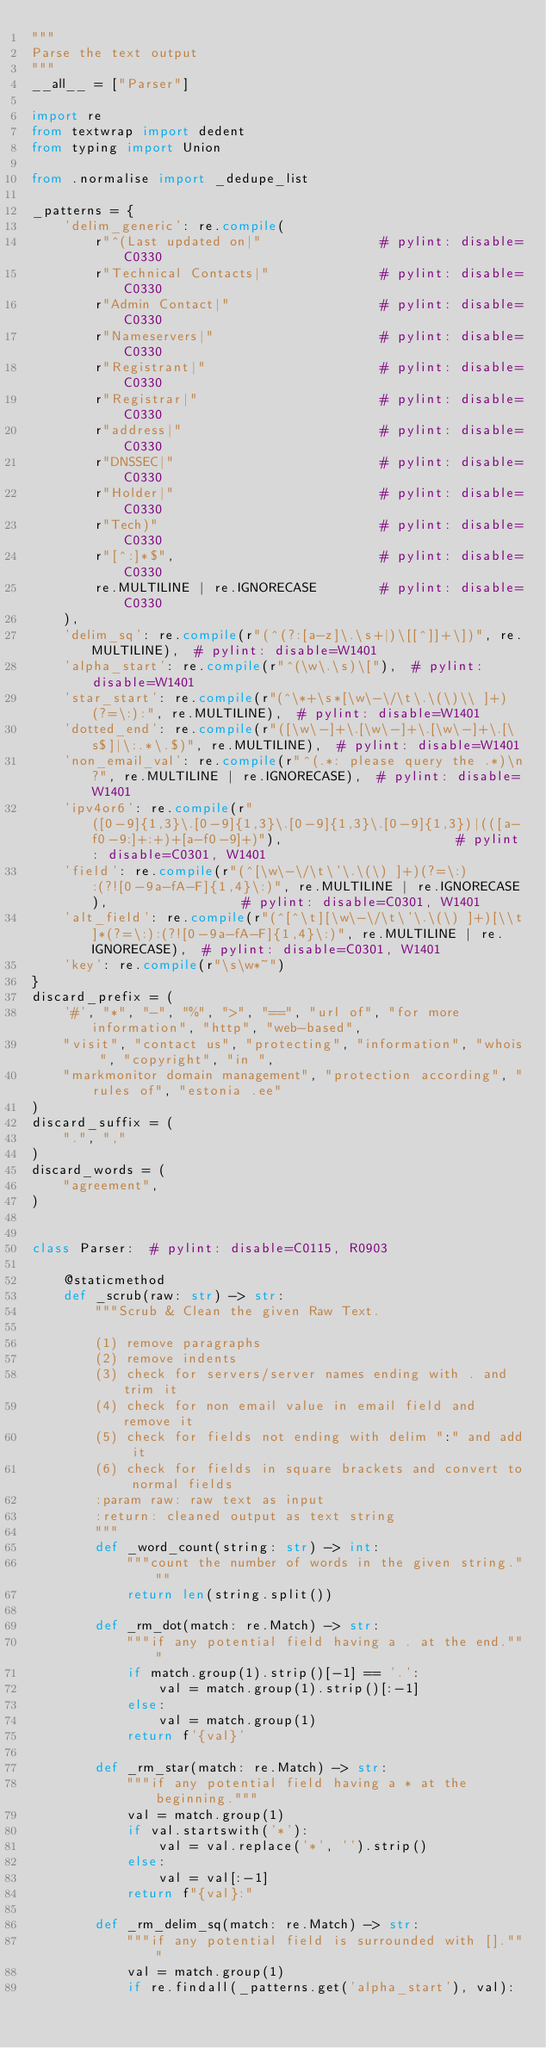<code> <loc_0><loc_0><loc_500><loc_500><_Python_>"""
Parse the text output
"""
__all__ = ["Parser"]

import re
from textwrap import dedent
from typing import Union

from .normalise import _dedupe_list

_patterns = {
    'delim_generic': re.compile(
        r"^(Last updated on|"               # pylint: disable=C0330
        r"Technical Contacts|"              # pylint: disable=C0330
        r"Admin Contact|"                   # pylint: disable=C0330
        r"Nameservers|"                     # pylint: disable=C0330
        r"Registrant|"                      # pylint: disable=C0330
        r"Registrar|"                       # pylint: disable=C0330
        r"address|"                         # pylint: disable=C0330
        r"DNSSEC|"                          # pylint: disable=C0330
        r"Holder|"                          # pylint: disable=C0330
        r"Tech)"                            # pylint: disable=C0330
        r"[^:]*$",                          # pylint: disable=C0330
        re.MULTILINE | re.IGNORECASE        # pylint: disable=C0330
    ),
    'delim_sq': re.compile(r"(^(?:[a-z]\.\s+|)\[[^]]+\])", re.MULTILINE),  # pylint: disable=W1401
    'alpha_start': re.compile(r"^(\w\.\s)\["),  # pylint: disable=W1401
    'star_start': re.compile(r"(^\*+\s*[\w\-\/\t\.\(\)\\ ]+)(?=\:):", re.MULTILINE),  # pylint: disable=W1401
    'dotted_end': re.compile(r"([\w\-]+\.[\w\-]+\.[\w\-]+\.[\s$]|\:.*\.$)", re.MULTILINE),  # pylint: disable=W1401
    'non_email_val': re.compile(r"^(.*: please query the .*)\n?", re.MULTILINE | re.IGNORECASE),  # pylint: disable=W1401
    'ipv4or6': re.compile(r"([0-9]{1,3}\.[0-9]{1,3}\.[0-9]{1,3}\.[0-9]{1,3})|(([a-f0-9:]+:+)+[a-f0-9]+)"),                      # pylint: disable=C0301, W1401
    'field': re.compile(r"(^[\w\-\/\t\'\.\(\) ]+)(?=\:):(?![0-9a-fA-F]{1,4}\:)", re.MULTILINE | re.IGNORECASE),                 # pylint: disable=C0301, W1401
    'alt_field': re.compile(r"(^[^\t][\w\-\/\t\'\.\(\) ]+)[\\t]*(?=\:):(?![0-9a-fA-F]{1,4}\:)", re.MULTILINE | re.IGNORECASE),  # pylint: disable=C0301, W1401
    'key': re.compile(r"\s\w*~")
}
discard_prefix = (
    '#', "*", "-", "%", ">", "==", "url of", "for more information", "http", "web-based",
    "visit", "contact us", "protecting", "information", "whois ", "copyright", "in ",
    "markmonitor domain management", "protection according", "rules of", "estonia .ee"
)
discard_suffix = (
    ".", ","
)
discard_words = (
    "agreement",
)


class Parser:  # pylint: disable=C0115, R0903

    @staticmethod
    def _scrub(raw: str) -> str:
        """Scrub & Clean the given Raw Text.

        (1) remove paragraphs
        (2) remove indents
        (3) check for servers/server names ending with . and trim it
        (4) check for non email value in email field and remove it
        (5) check for fields not ending with delim ":" and add it
        (6) check for fields in square brackets and convert to normal fields
        :param raw: raw text as input
        :return: cleaned output as text string
        """
        def _word_count(string: str) -> int:
            """count the number of words in the given string."""
            return len(string.split())

        def _rm_dot(match: re.Match) -> str:
            """if any potential field having a . at the end."""
            if match.group(1).strip()[-1] == '.':
                val = match.group(1).strip()[:-1]
            else:
                val = match.group(1)
            return f'{val}'

        def _rm_star(match: re.Match) -> str:
            """if any potential field having a * at the beginning."""
            val = match.group(1)
            if val.startswith('*'):
                val = val.replace('*', '').strip()
            else:
                val = val[:-1]
            return f"{val}:"

        def _rm_delim_sq(match: re.Match) -> str:
            """if any potential field is surrounded with []."""
            val = match.group(1)
            if re.findall(_patterns.get('alpha_start'), val):</code> 